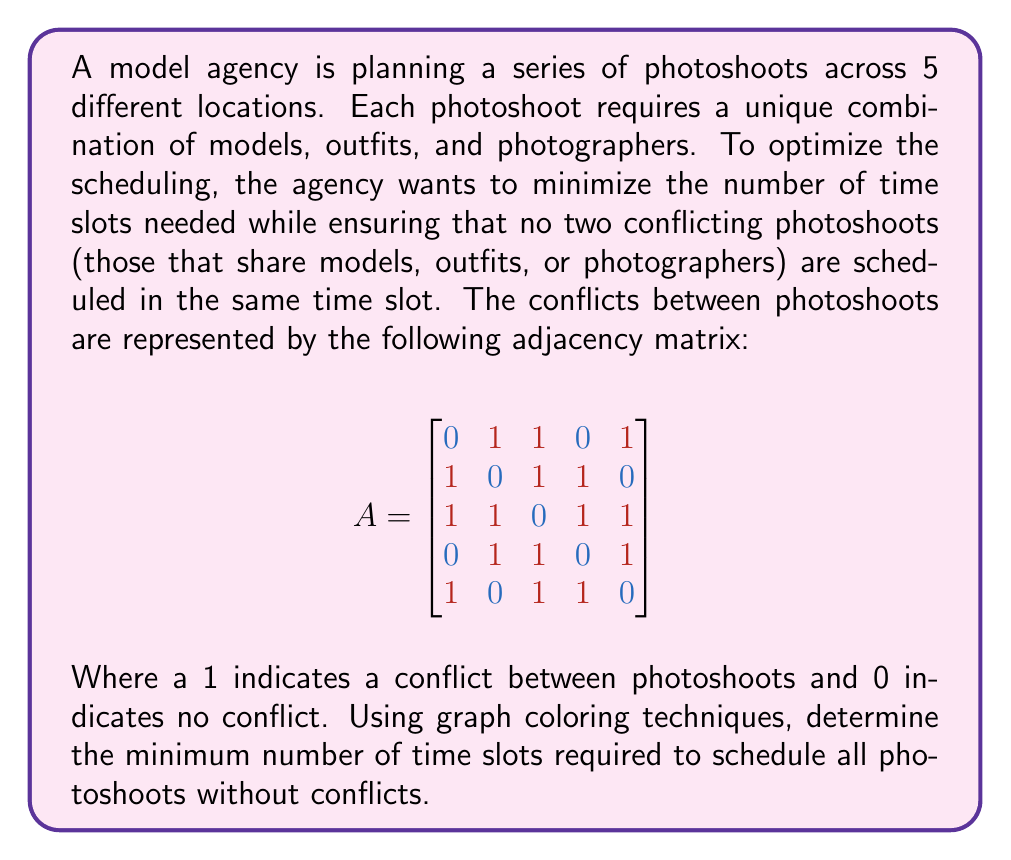Teach me how to tackle this problem. To solve this problem, we can use graph coloring techniques. Each photoshoot location represents a vertex in the graph, and conflicts between photoshoots are represented by edges. The goal is to find the chromatic number of the graph, which is the minimum number of colors (time slots) needed to color all vertices such that no adjacent vertices have the same color.

Step 1: Construct the graph based on the adjacency matrix.

[asy]
unitsize(1cm);
pair[] v = {(0,0), (2,0), (1,1.732), (-1,1.732), (-2,0)};
for(int i = 0; i < 5; ++i) {
  dot(v[i]);
  label("" + (i+1), v[i], dir(45));
}
draw(v[0]--v[1]--v[2]--v[3]--v[4]--v[2]);
draw(v[0]--v[2]--v[4]);
draw(v[1]--v[3]);
[/asy]

Step 2: Apply a graph coloring algorithm. We'll use the greedy coloring algorithm for this example.

1. Start with vertex 1:
   - Assign color 1 to vertex 1

2. Move to vertex 2:
   - It's adjacent to vertex 1, so assign color 2

3. For vertex 3:
   - Adjacent to 1 and 2, so assign color 3

4. For vertex 4:
   - Adjacent to 2 and 3, but not 1, so assign color 1

5. For vertex 5:
   - Adjacent to 1 and 3, but not 2, so assign color 2

Step 3: Count the number of unique colors used.

In this case, we used 3 colors (time slots) to color all vertices without conflicts.

Step 4: Verify that this is the minimum number of colors needed.

We can observe that vertices 1, 2, and 3 form a triangle, meaning they all conflict with each other. Therefore, they must each have a different color, requiring at least 3 colors. Since we found a valid 3-coloring, this is indeed the minimum number of colors (time slots) needed.
Answer: The minimum number of time slots required to schedule all photoshoots without conflicts is 3. 